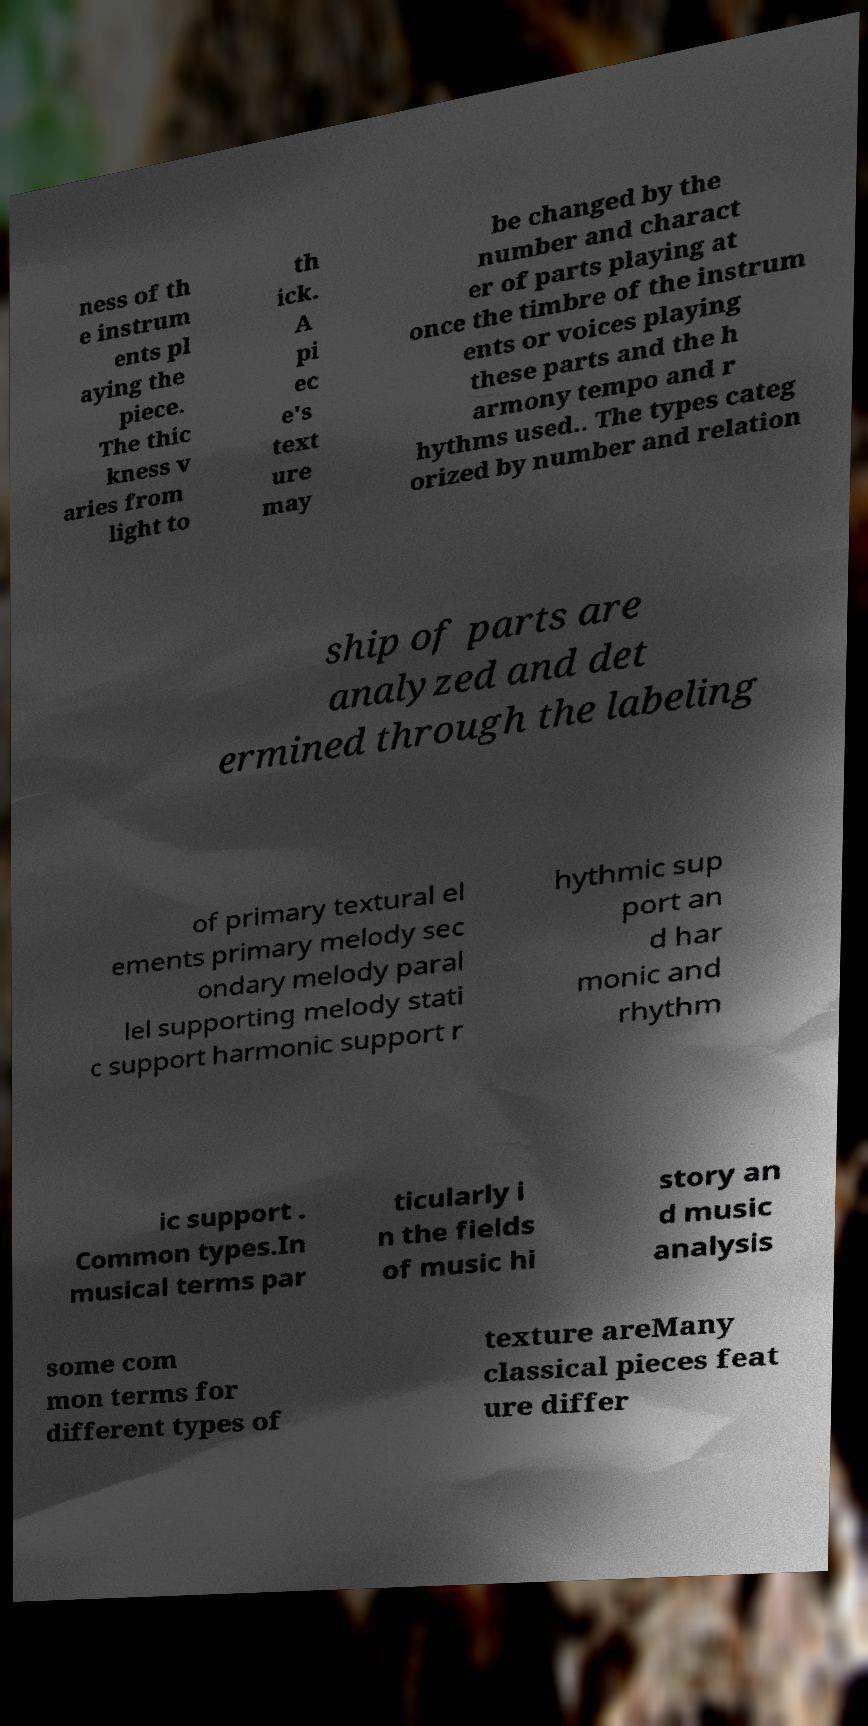Can you read and provide the text displayed in the image?This photo seems to have some interesting text. Can you extract and type it out for me? ness of th e instrum ents pl aying the piece. The thic kness v aries from light to th ick. A pi ec e's text ure may be changed by the number and charact er of parts playing at once the timbre of the instrum ents or voices playing these parts and the h armony tempo and r hythms used.. The types categ orized by number and relation ship of parts are analyzed and det ermined through the labeling of primary textural el ements primary melody sec ondary melody paral lel supporting melody stati c support harmonic support r hythmic sup port an d har monic and rhythm ic support . Common types.In musical terms par ticularly i n the fields of music hi story an d music analysis some com mon terms for different types of texture areMany classical pieces feat ure differ 